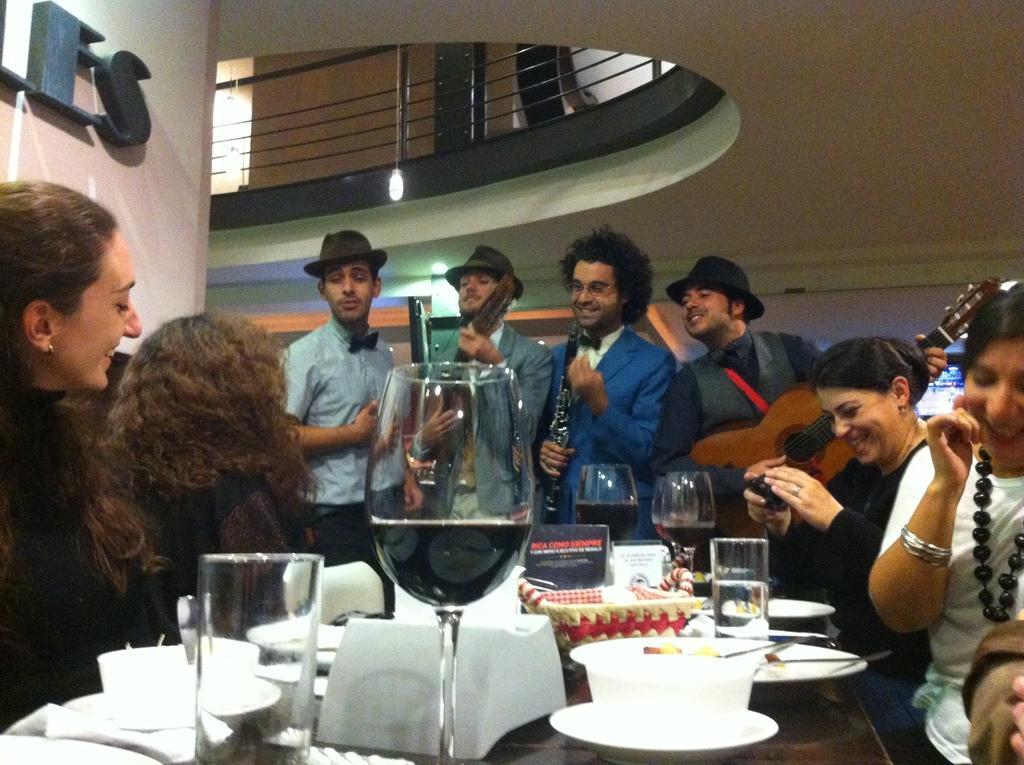Could you give a brief overview of what you see in this image? This picture shows four men standing and holding musical instruments in their hands and we see four women seated on the chairs and we see a woman holding a camera in her hand. we see some wine glasses cups and plates on the table 